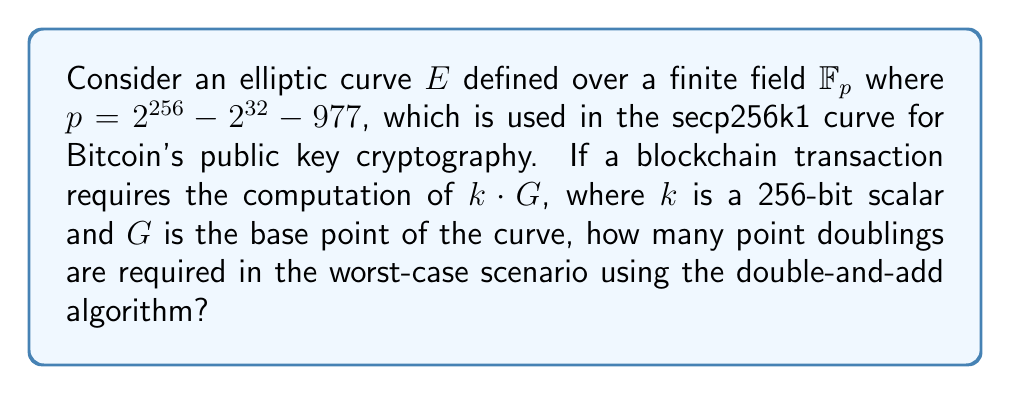Could you help me with this problem? To solve this problem, we need to consider the following steps:

1) The secp256k1 curve is used in Bitcoin's elliptic curve cryptography, which operates over a finite field with prime $p = 2^{256} - 2^{32} - 977$.

2) The scalar $k$ is a 256-bit number, meaning it can be any integer from 0 to $2^{256} - 1$.

3) The double-and-add algorithm is used for point multiplication on elliptic curves. It works by scanning the bits of $k$ from left to right.

4) In each step of the algorithm:
   - A point doubling is always performed.
   - If the current bit of $k$ is 1, a point addition is also performed.

5) The worst-case scenario occurs when $k$ has the maximum number of bits set to 1, which is 256 for a 256-bit number.

6) In the double-and-add algorithm, the number of doublings is always equal to the number of bits in $k$, minus one (because we start with the base point for the first bit).

7) Therefore, the number of doublings required in the worst-case scenario is:

   $$256 - 1 = 255$$

This means that regardless of the specific value of $k$, as long as it's a 256-bit number, we will always perform 255 point doublings in the worst case.
Answer: 255 